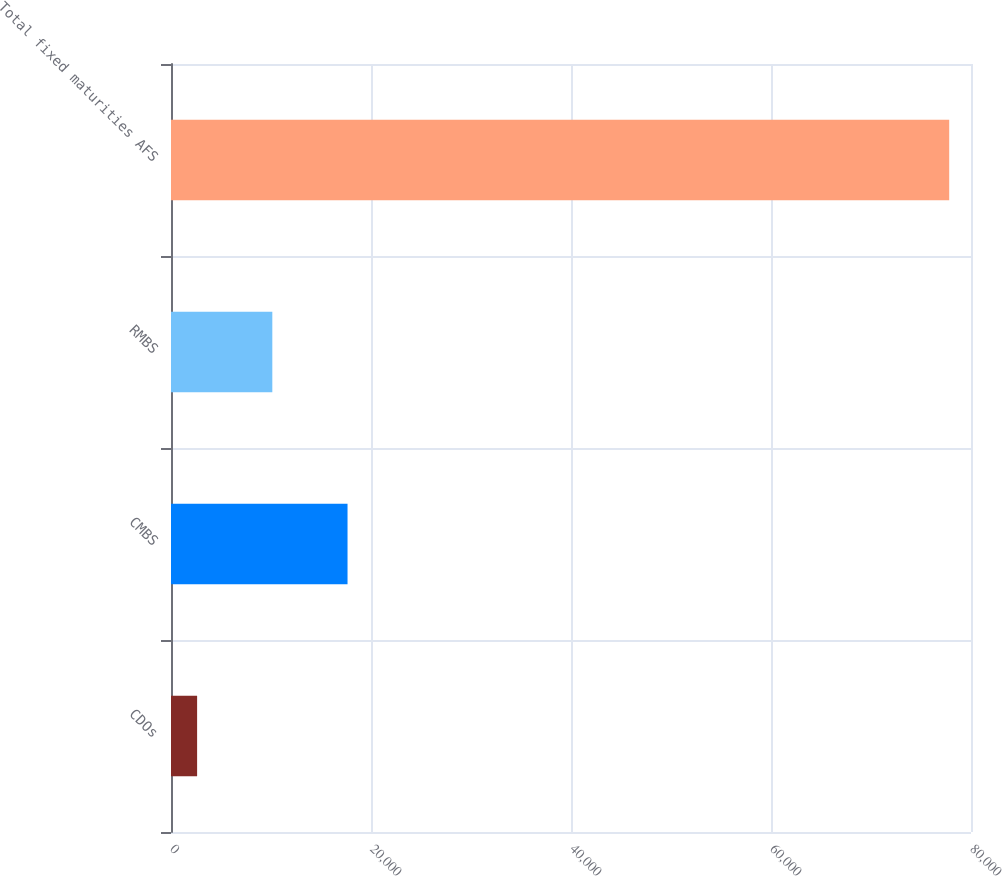Convert chart. <chart><loc_0><loc_0><loc_500><loc_500><bar_chart><fcel>CDOs<fcel>CMBS<fcel>RMBS<fcel>Total fixed maturities AFS<nl><fcel>2611<fcel>17652.8<fcel>10131.9<fcel>77820<nl></chart> 